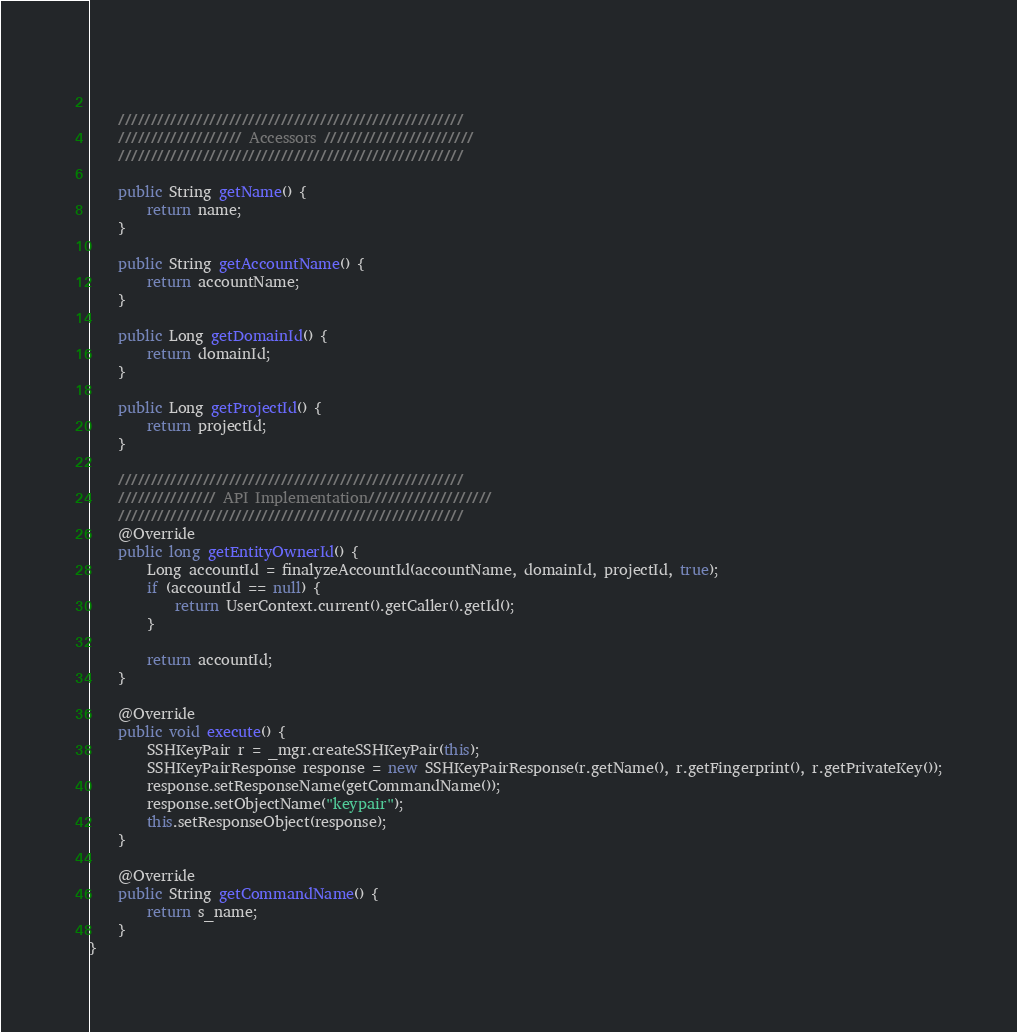Convert code to text. <code><loc_0><loc_0><loc_500><loc_500><_Java_>	
    
    /////////////////////////////////////////////////////
    /////////////////// Accessors ///////////////////////
    /////////////////////////////////////////////////////
    
	public String getName() {
		return name;
	}
	
    public String getAccountName() {
        return accountName;
    }
    
    public Long getDomainId() {
        return domainId;
    }

    public Long getProjectId() {
        return projectId;
    }
	
    /////////////////////////////////////////////////////
    /////////////// API Implementation///////////////////
	/////////////////////////////////////////////////////
    @Override
    public long getEntityOwnerId() {
        Long accountId = finalyzeAccountId(accountName, domainId, projectId, true);
        if (accountId == null) {
            return UserContext.current().getCaller().getId();
        }
        
        return accountId;
    }   

	@Override
	public void execute() {
		SSHKeyPair r = _mgr.createSSHKeyPair(this);
		SSHKeyPairResponse response = new SSHKeyPairResponse(r.getName(), r.getFingerprint(), r.getPrivateKey());
		response.setResponseName(getCommandName());
		response.setObjectName("keypair");
		this.setResponseObject(response);
	}

	@Override
	public String getCommandName() {
		return s_name;
	}
}
</code> 